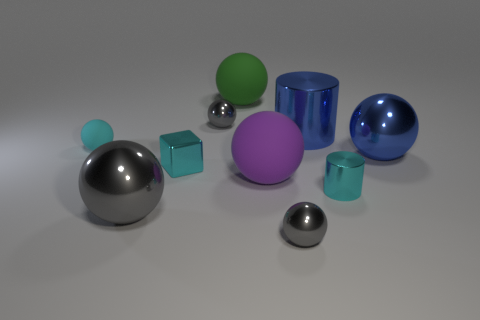There is a gray thing that is behind the cyan cylinder; does it have the same size as the large purple ball?
Your answer should be very brief. No. How many other things are there of the same material as the cube?
Offer a terse response. 6. How many cyan objects are either tiny metallic objects or large matte cubes?
Your answer should be compact. 2. There is a shiny thing that is the same color as the cube; what is its size?
Offer a very short reply. Small. There is a blue cylinder; what number of large matte balls are behind it?
Keep it short and to the point. 1. There is a sphere in front of the big metal thing that is left of the small gray metal sphere behind the tiny matte object; what is its size?
Provide a succinct answer. Small. Are there any gray spheres that are in front of the cyan metallic object that is on the left side of the big ball behind the big blue sphere?
Make the answer very short. Yes. Is the number of cyan metallic cylinders greater than the number of large blue objects?
Your answer should be compact. No. What is the color of the large rubber object behind the cyan ball?
Keep it short and to the point. Green. Is the number of large matte objects behind the big gray shiny sphere greater than the number of rubber cylinders?
Make the answer very short. Yes. 